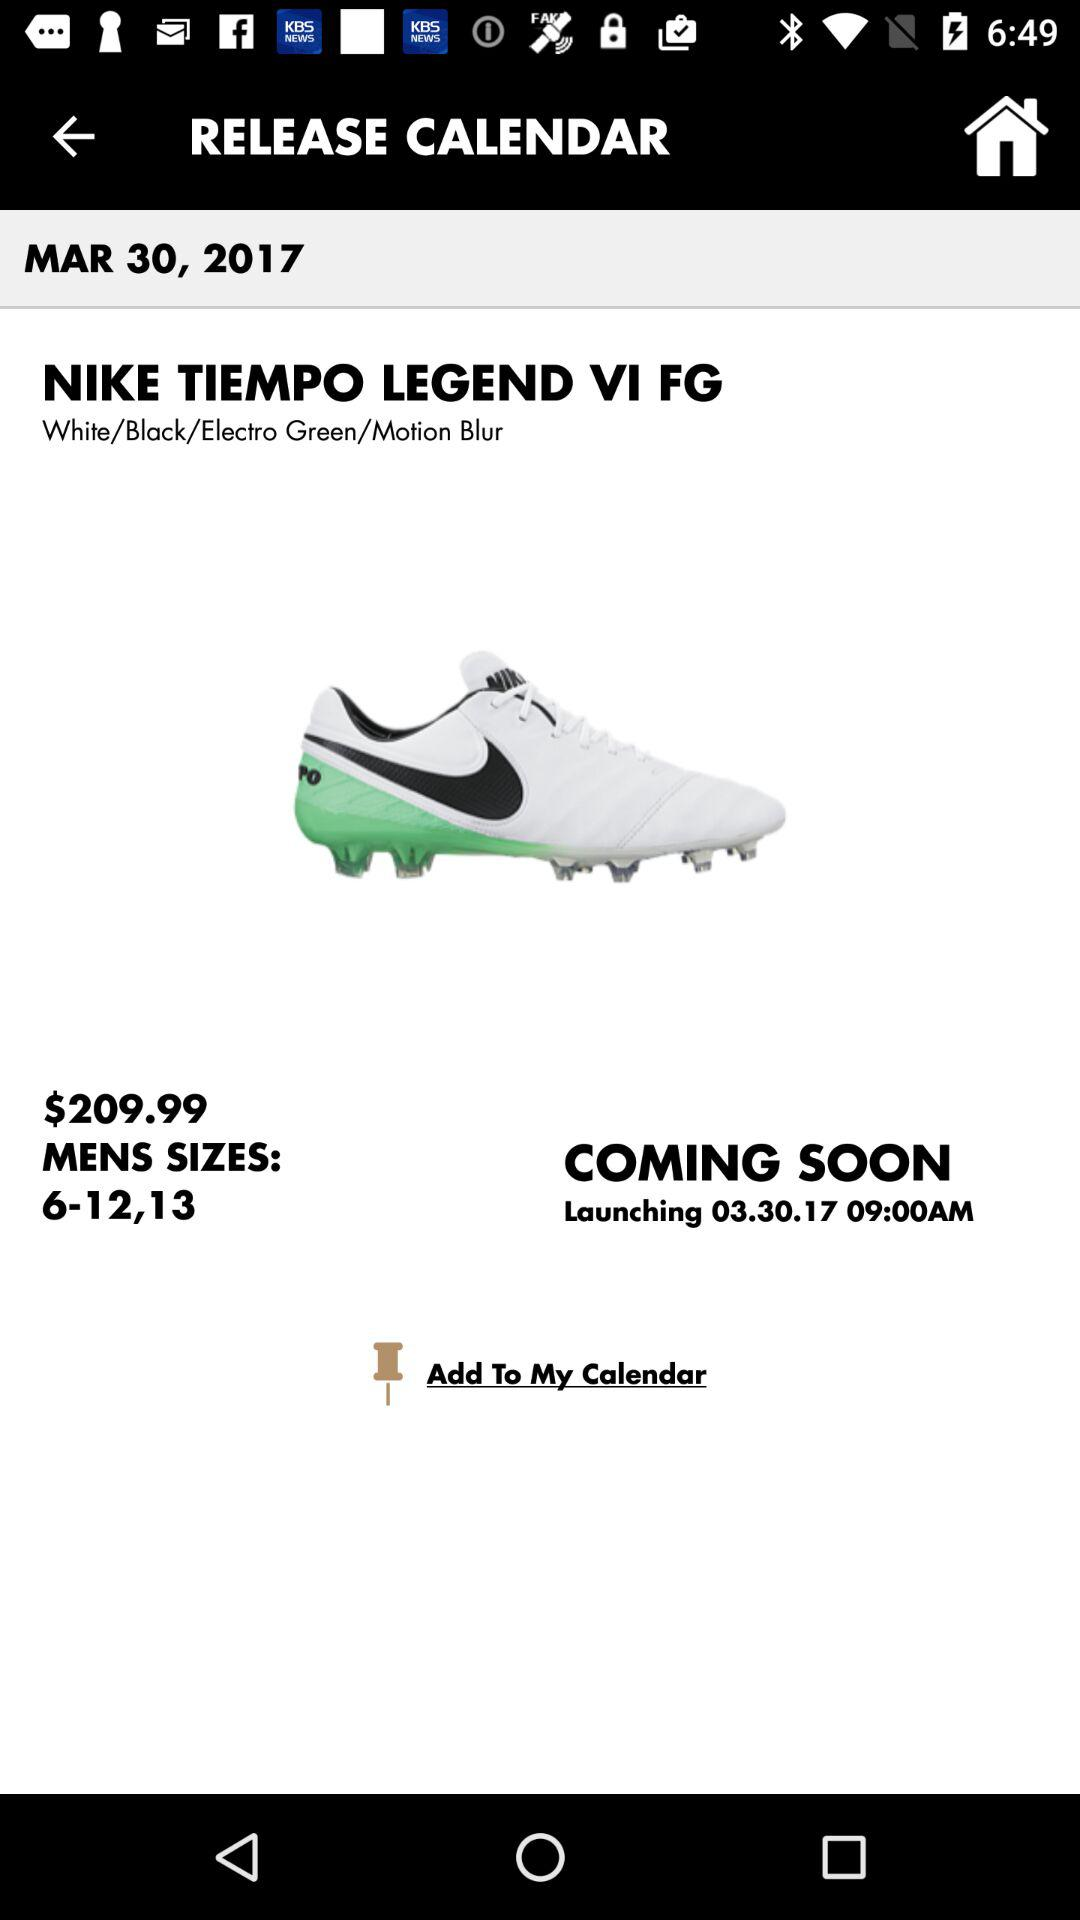What is the shoe size? The shoe sizes are 6–12 and 13. 